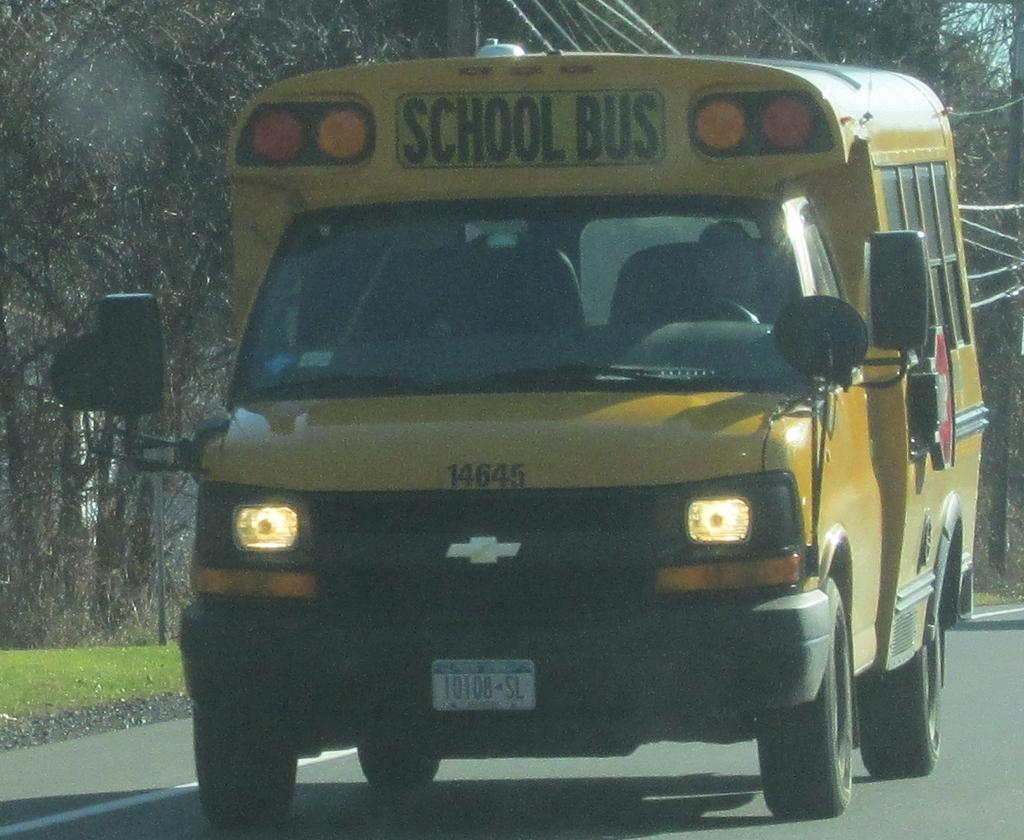What is the main subject in the center of the image? There is a bus in the center of the image. Where is the bus located? The bus is on the road. What can be seen in the background of the image? There are trees, a current pole, cables, gravel, and grass in the background of the image. What is the tendency of the bus to fall over in the image? The image does not show any indication of the bus falling over, and therefore it is not possible to determine its tendency to do so. 